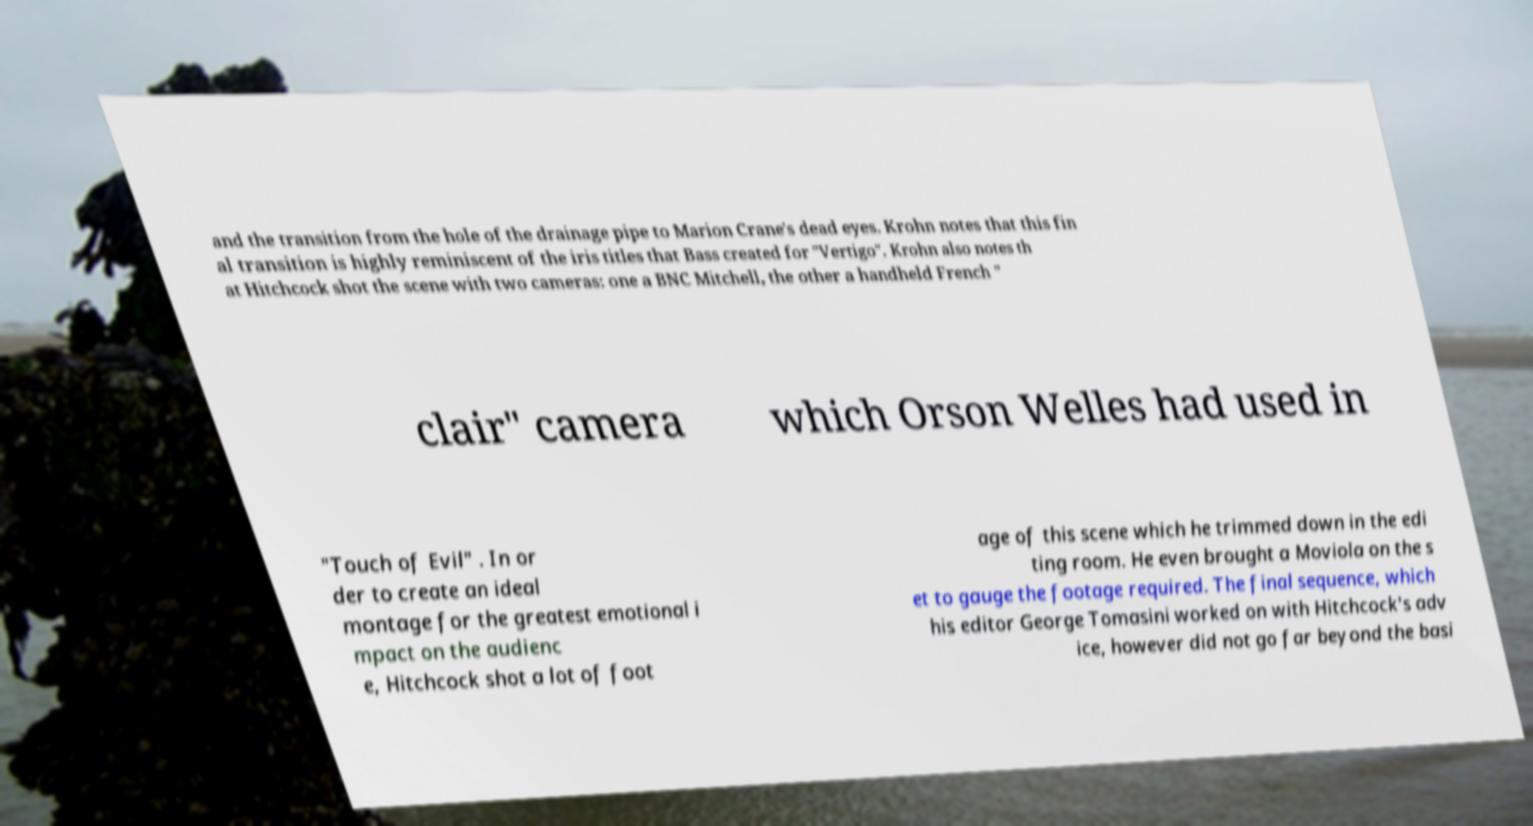For documentation purposes, I need the text within this image transcribed. Could you provide that? and the transition from the hole of the drainage pipe to Marion Crane's dead eyes. Krohn notes that this fin al transition is highly reminiscent of the iris titles that Bass created for "Vertigo". Krohn also notes th at Hitchcock shot the scene with two cameras: one a BNC Mitchell, the other a handheld French " clair" camera which Orson Welles had used in "Touch of Evil" . In or der to create an ideal montage for the greatest emotional i mpact on the audienc e, Hitchcock shot a lot of foot age of this scene which he trimmed down in the edi ting room. He even brought a Moviola on the s et to gauge the footage required. The final sequence, which his editor George Tomasini worked on with Hitchcock's adv ice, however did not go far beyond the basi 